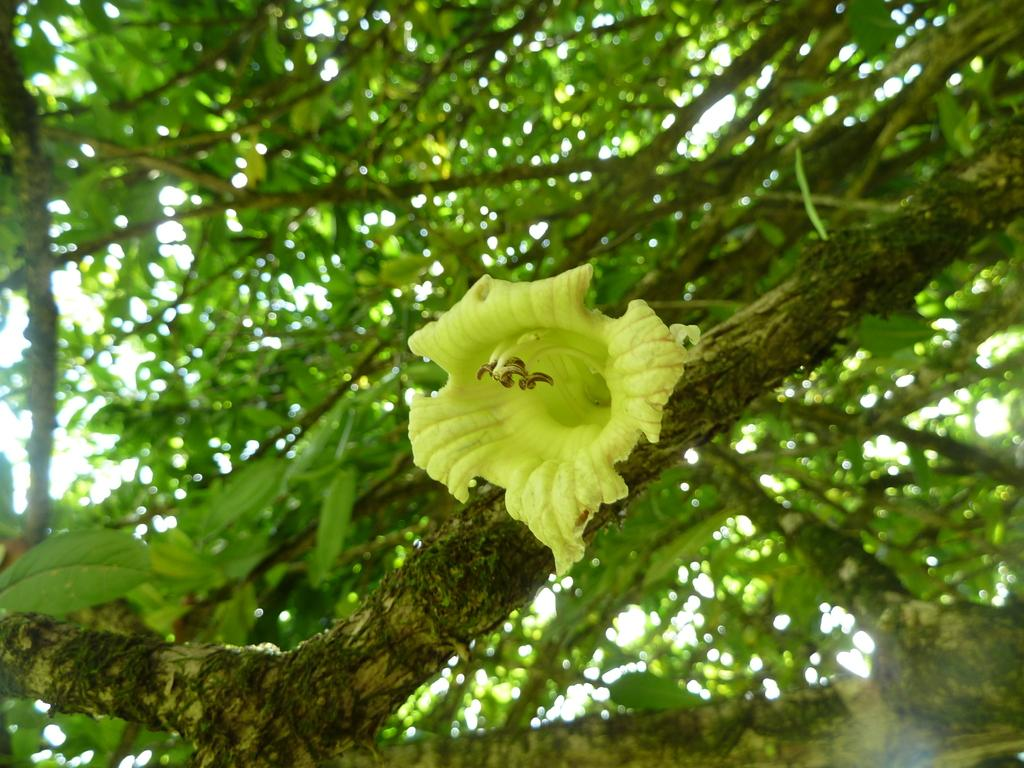What type of plant can be seen on a tree branch in the image? There is a flower on a tree branch in the image. What else can be seen on the branches of the trees in the image? There are many leaves on the branches of the trees in the image. What type of appliance is hanging from the tree branch in the image? There is no appliance present in the image; it only features a flower on a tree branch and leaves on the branches. 